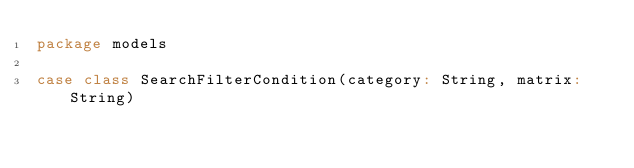<code> <loc_0><loc_0><loc_500><loc_500><_Scala_>package models

case class SearchFilterCondition(category: String, matrix: String)</code> 